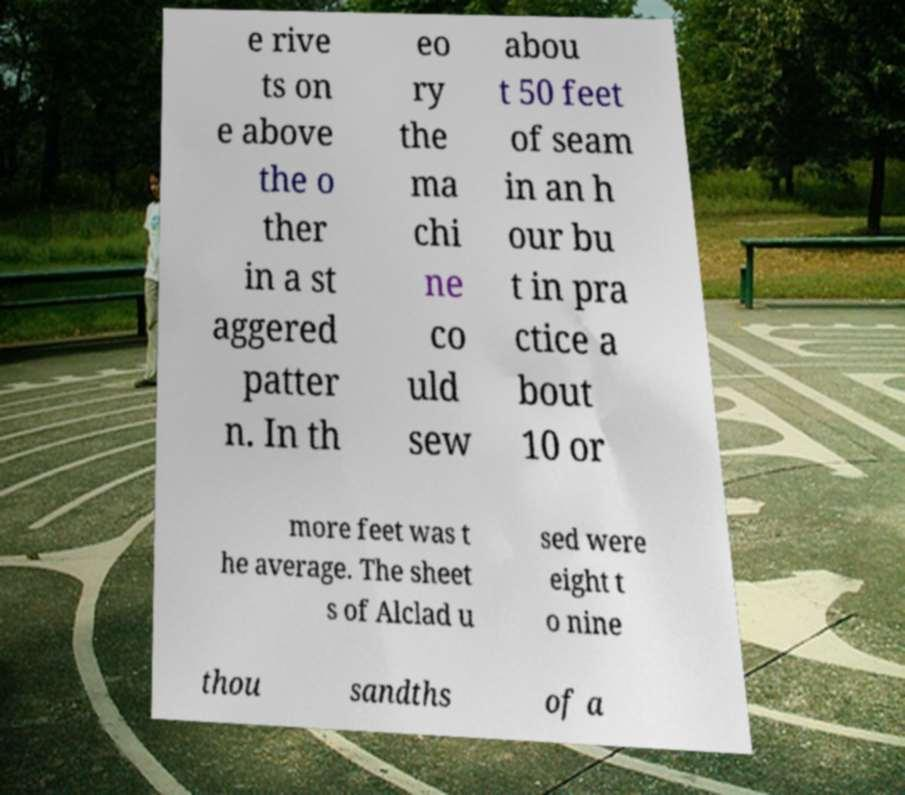I need the written content from this picture converted into text. Can you do that? e rive ts on e above the o ther in a st aggered patter n. In th eo ry the ma chi ne co uld sew abou t 50 feet of seam in an h our bu t in pra ctice a bout 10 or more feet was t he average. The sheet s of Alclad u sed were eight t o nine thou sandths of a 